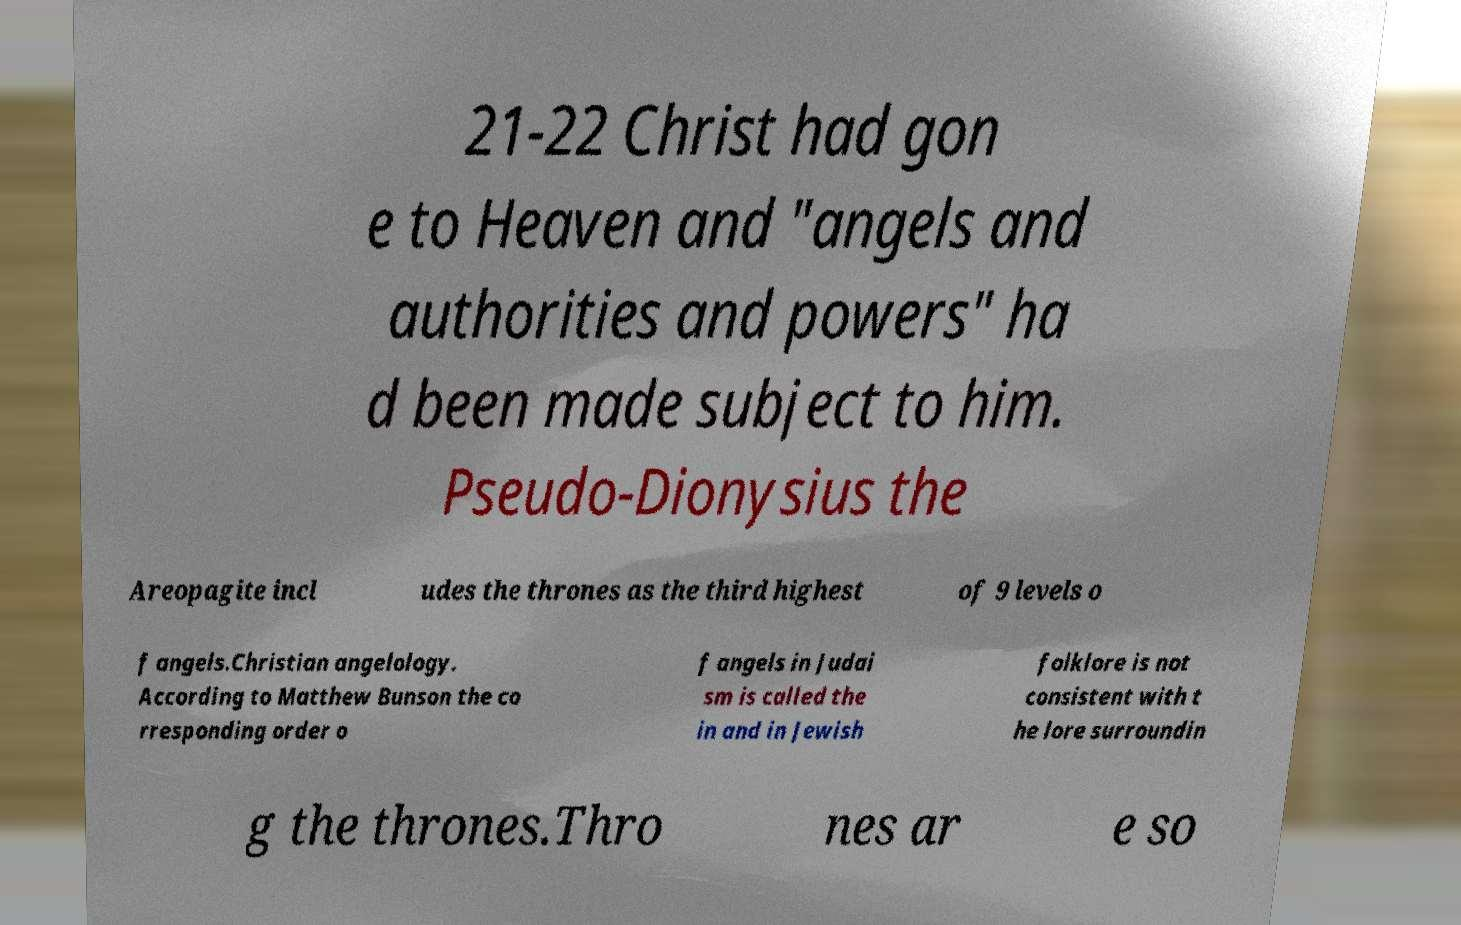Could you assist in decoding the text presented in this image and type it out clearly? 21-22 Christ had gon e to Heaven and "angels and authorities and powers" ha d been made subject to him. Pseudo-Dionysius the Areopagite incl udes the thrones as the third highest of 9 levels o f angels.Christian angelology. According to Matthew Bunson the co rresponding order o f angels in Judai sm is called the in and in Jewish folklore is not consistent with t he lore surroundin g the thrones.Thro nes ar e so 